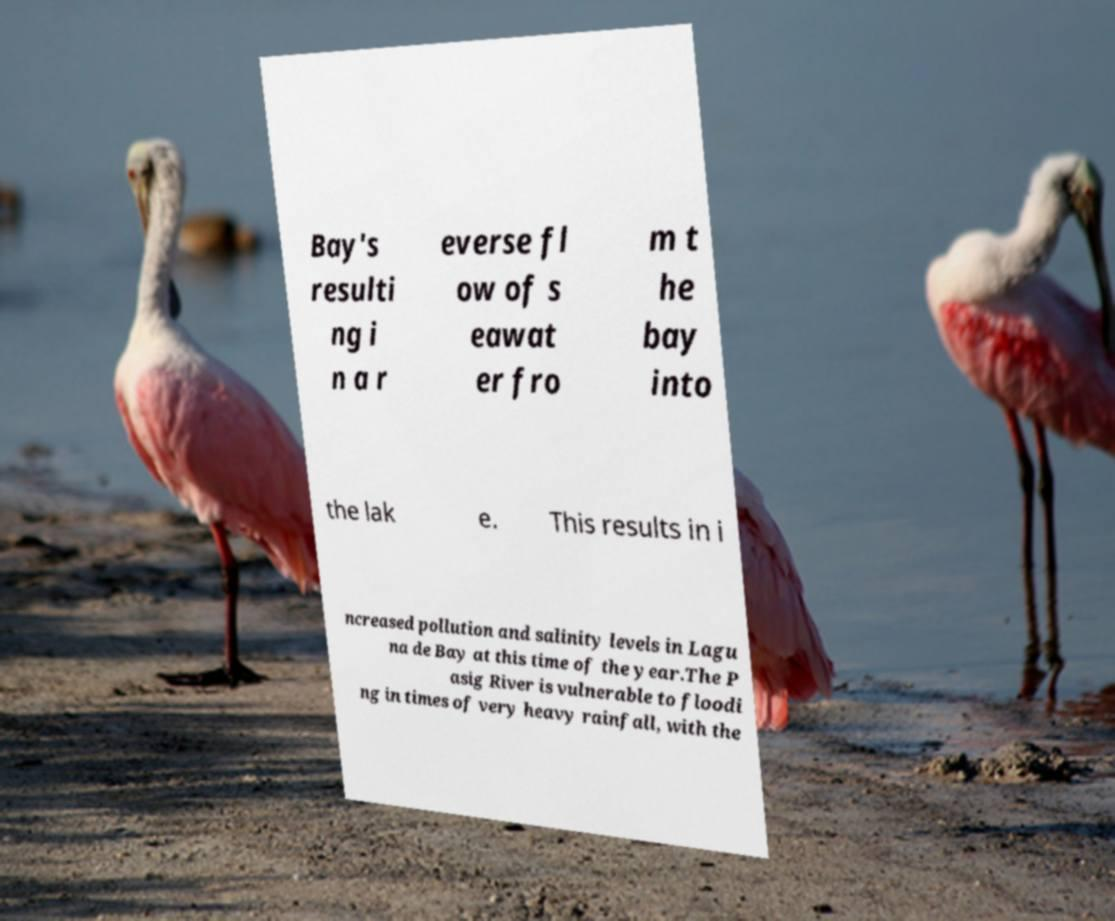Please read and relay the text visible in this image. What does it say? Bay's resulti ng i n a r everse fl ow of s eawat er fro m t he bay into the lak e. This results in i ncreased pollution and salinity levels in Lagu na de Bay at this time of the year.The P asig River is vulnerable to floodi ng in times of very heavy rainfall, with the 